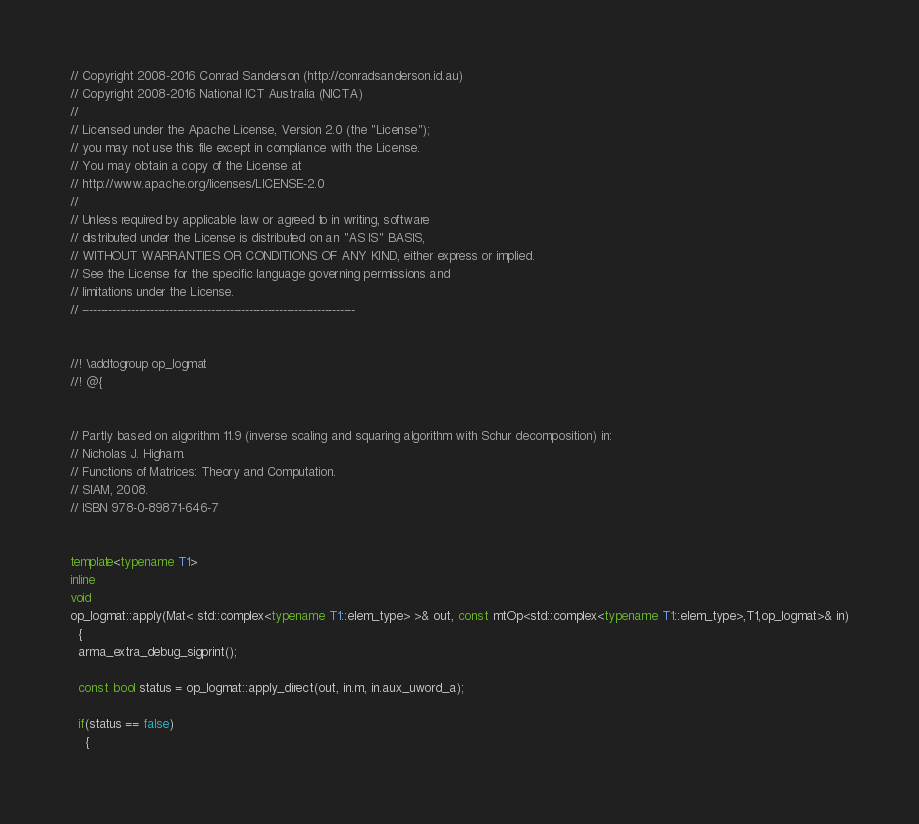<code> <loc_0><loc_0><loc_500><loc_500><_C++_>// Copyright 2008-2016 Conrad Sanderson (http://conradsanderson.id.au)
// Copyright 2008-2016 National ICT Australia (NICTA)
//
// Licensed under the Apache License, Version 2.0 (the "License");
// you may not use this file except in compliance with the License.
// You may obtain a copy of the License at
// http://www.apache.org/licenses/LICENSE-2.0
//
// Unless required by applicable law or agreed to in writing, software
// distributed under the License is distributed on an "AS IS" BASIS,
// WITHOUT WARRANTIES OR CONDITIONS OF ANY KIND, either express or implied.
// See the License for the specific language governing permissions and
// limitations under the License.
// ------------------------------------------------------------------------


//! \addtogroup op_logmat
//! @{


// Partly based on algorithm 11.9 (inverse scaling and squaring algorithm with Schur decomposition) in:
// Nicholas J. Higham.
// Functions of Matrices: Theory and Computation.
// SIAM, 2008.
// ISBN 978-0-89871-646-7


template<typename T1>
inline
void
op_logmat::apply(Mat< std::complex<typename T1::elem_type> >& out, const mtOp<std::complex<typename T1::elem_type>,T1,op_logmat>& in)
  {
  arma_extra_debug_sigprint();

  const bool status = op_logmat::apply_direct(out, in.m, in.aux_uword_a);

  if(status == false)
    {</code> 